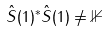<formula> <loc_0><loc_0><loc_500><loc_500>\hat { S } ( 1 ) ^ { * } \hat { S } ( 1 ) \ne \mathbb { 1 }</formula> 